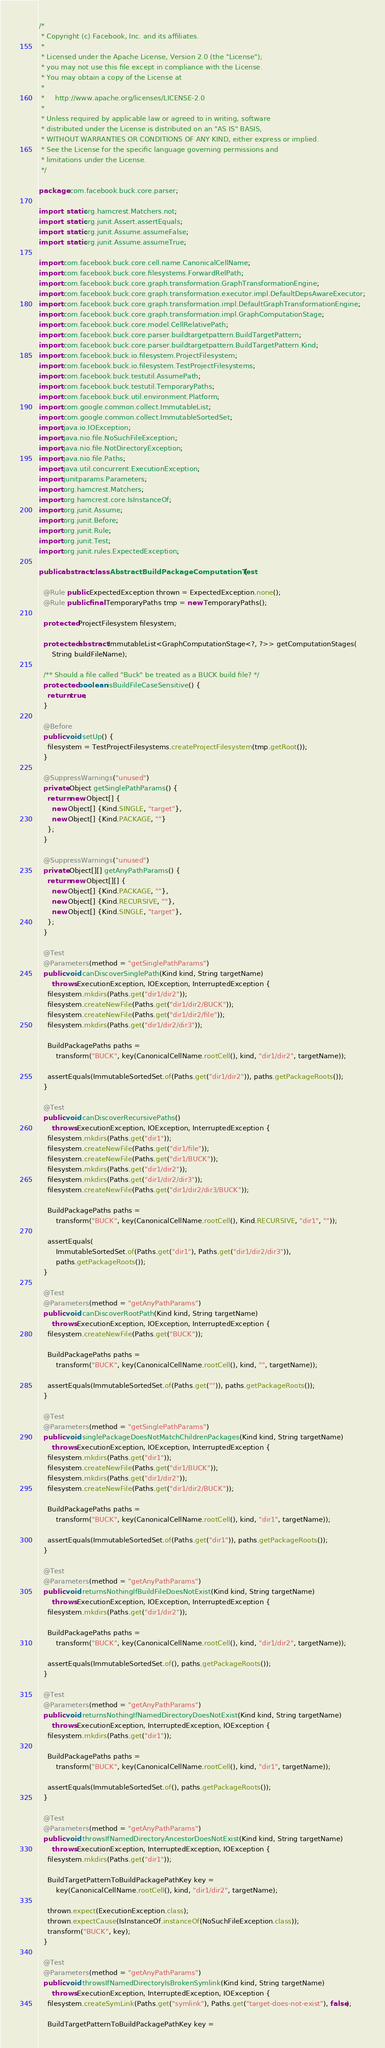<code> <loc_0><loc_0><loc_500><loc_500><_Java_>/*
 * Copyright (c) Facebook, Inc. and its affiliates.
 *
 * Licensed under the Apache License, Version 2.0 (the "License");
 * you may not use this file except in compliance with the License.
 * You may obtain a copy of the License at
 *
 *     http://www.apache.org/licenses/LICENSE-2.0
 *
 * Unless required by applicable law or agreed to in writing, software
 * distributed under the License is distributed on an "AS IS" BASIS,
 * WITHOUT WARRANTIES OR CONDITIONS OF ANY KIND, either express or implied.
 * See the License for the specific language governing permissions and
 * limitations under the License.
 */

package com.facebook.buck.core.parser;

import static org.hamcrest.Matchers.not;
import static org.junit.Assert.assertEquals;
import static org.junit.Assume.assumeFalse;
import static org.junit.Assume.assumeTrue;

import com.facebook.buck.core.cell.name.CanonicalCellName;
import com.facebook.buck.core.filesystems.ForwardRelPath;
import com.facebook.buck.core.graph.transformation.GraphTransformationEngine;
import com.facebook.buck.core.graph.transformation.executor.impl.DefaultDepsAwareExecutor;
import com.facebook.buck.core.graph.transformation.impl.DefaultGraphTransformationEngine;
import com.facebook.buck.core.graph.transformation.impl.GraphComputationStage;
import com.facebook.buck.core.model.CellRelativePath;
import com.facebook.buck.core.parser.buildtargetpattern.BuildTargetPattern;
import com.facebook.buck.core.parser.buildtargetpattern.BuildTargetPattern.Kind;
import com.facebook.buck.io.filesystem.ProjectFilesystem;
import com.facebook.buck.io.filesystem.TestProjectFilesystems;
import com.facebook.buck.testutil.AssumePath;
import com.facebook.buck.testutil.TemporaryPaths;
import com.facebook.buck.util.environment.Platform;
import com.google.common.collect.ImmutableList;
import com.google.common.collect.ImmutableSortedSet;
import java.io.IOException;
import java.nio.file.NoSuchFileException;
import java.nio.file.NotDirectoryException;
import java.nio.file.Paths;
import java.util.concurrent.ExecutionException;
import junitparams.Parameters;
import org.hamcrest.Matchers;
import org.hamcrest.core.IsInstanceOf;
import org.junit.Assume;
import org.junit.Before;
import org.junit.Rule;
import org.junit.Test;
import org.junit.rules.ExpectedException;

public abstract class AbstractBuildPackageComputationTest {

  @Rule public ExpectedException thrown = ExpectedException.none();
  @Rule public final TemporaryPaths tmp = new TemporaryPaths();

  protected ProjectFilesystem filesystem;

  protected abstract ImmutableList<GraphComputationStage<?, ?>> getComputationStages(
      String buildFileName);

  /** Should a file called "Buck" be treated as a BUCK build file? */
  protected boolean isBuildFileCaseSensitive() {
    return true;
  }

  @Before
  public void setUp() {
    filesystem = TestProjectFilesystems.createProjectFilesystem(tmp.getRoot());
  }

  @SuppressWarnings("unused")
  private Object getSinglePathParams() {
    return new Object[] {
      new Object[] {Kind.SINGLE, "target"},
      new Object[] {Kind.PACKAGE, ""}
    };
  }

  @SuppressWarnings("unused")
  private Object[][] getAnyPathParams() {
    return new Object[][] {
      new Object[] {Kind.PACKAGE, ""},
      new Object[] {Kind.RECURSIVE, ""},
      new Object[] {Kind.SINGLE, "target"},
    };
  }

  @Test
  @Parameters(method = "getSinglePathParams")
  public void canDiscoverSinglePath(Kind kind, String targetName)
      throws ExecutionException, IOException, InterruptedException {
    filesystem.mkdirs(Paths.get("dir1/dir2"));
    filesystem.createNewFile(Paths.get("dir1/dir2/BUCK"));
    filesystem.createNewFile(Paths.get("dir1/dir2/file"));
    filesystem.mkdirs(Paths.get("dir1/dir2/dir3"));

    BuildPackagePaths paths =
        transform("BUCK", key(CanonicalCellName.rootCell(), kind, "dir1/dir2", targetName));

    assertEquals(ImmutableSortedSet.of(Paths.get("dir1/dir2")), paths.getPackageRoots());
  }

  @Test
  public void canDiscoverRecursivePaths()
      throws ExecutionException, IOException, InterruptedException {
    filesystem.mkdirs(Paths.get("dir1"));
    filesystem.createNewFile(Paths.get("dir1/file"));
    filesystem.createNewFile(Paths.get("dir1/BUCK"));
    filesystem.mkdirs(Paths.get("dir1/dir2"));
    filesystem.mkdirs(Paths.get("dir1/dir2/dir3"));
    filesystem.createNewFile(Paths.get("dir1/dir2/dir3/BUCK"));

    BuildPackagePaths paths =
        transform("BUCK", key(CanonicalCellName.rootCell(), Kind.RECURSIVE, "dir1", ""));

    assertEquals(
        ImmutableSortedSet.of(Paths.get("dir1"), Paths.get("dir1/dir2/dir3")),
        paths.getPackageRoots());
  }

  @Test
  @Parameters(method = "getAnyPathParams")
  public void canDiscoverRootPath(Kind kind, String targetName)
      throws ExecutionException, IOException, InterruptedException {
    filesystem.createNewFile(Paths.get("BUCK"));

    BuildPackagePaths paths =
        transform("BUCK", key(CanonicalCellName.rootCell(), kind, "", targetName));

    assertEquals(ImmutableSortedSet.of(Paths.get("")), paths.getPackageRoots());
  }

  @Test
  @Parameters(method = "getSinglePathParams")
  public void singlePackageDoesNotMatchChildrenPackages(Kind kind, String targetName)
      throws ExecutionException, IOException, InterruptedException {
    filesystem.mkdirs(Paths.get("dir1"));
    filesystem.createNewFile(Paths.get("dir1/BUCK"));
    filesystem.mkdirs(Paths.get("dir1/dir2"));
    filesystem.createNewFile(Paths.get("dir1/dir2/BUCK"));

    BuildPackagePaths paths =
        transform("BUCK", key(CanonicalCellName.rootCell(), kind, "dir1", targetName));

    assertEquals(ImmutableSortedSet.of(Paths.get("dir1")), paths.getPackageRoots());
  }

  @Test
  @Parameters(method = "getAnyPathParams")
  public void returnsNothingIfBuildFileDoesNotExist(Kind kind, String targetName)
      throws ExecutionException, IOException, InterruptedException {
    filesystem.mkdirs(Paths.get("dir1/dir2"));

    BuildPackagePaths paths =
        transform("BUCK", key(CanonicalCellName.rootCell(), kind, "dir1/dir2", targetName));

    assertEquals(ImmutableSortedSet.of(), paths.getPackageRoots());
  }

  @Test
  @Parameters(method = "getAnyPathParams")
  public void returnsNothingIfNamedDirectoryDoesNotExist(Kind kind, String targetName)
      throws ExecutionException, InterruptedException, IOException {
    filesystem.mkdirs(Paths.get("dir1"));

    BuildPackagePaths paths =
        transform("BUCK", key(CanonicalCellName.rootCell(), kind, "dir1", targetName));

    assertEquals(ImmutableSortedSet.of(), paths.getPackageRoots());
  }

  @Test
  @Parameters(method = "getAnyPathParams")
  public void throwsIfNamedDirectoryAncestorDoesNotExist(Kind kind, String targetName)
      throws ExecutionException, InterruptedException, IOException {
    filesystem.mkdirs(Paths.get("dir1"));

    BuildTargetPatternToBuildPackagePathKey key =
        key(CanonicalCellName.rootCell(), kind, "dir1/dir2", targetName);

    thrown.expect(ExecutionException.class);
    thrown.expectCause(IsInstanceOf.instanceOf(NoSuchFileException.class));
    transform("BUCK", key);
  }

  @Test
  @Parameters(method = "getAnyPathParams")
  public void throwsIfNamedDirectoryIsBrokenSymlink(Kind kind, String targetName)
      throws ExecutionException, InterruptedException, IOException {
    filesystem.createSymLink(Paths.get("symlink"), Paths.get("target-does-not-exist"), false);

    BuildTargetPatternToBuildPackagePathKey key =</code> 